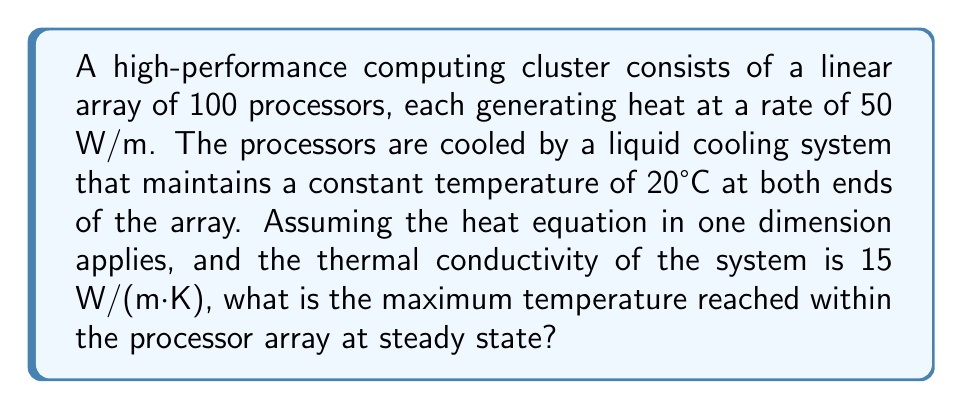Teach me how to tackle this problem. To solve this problem, we'll use the steady-state heat equation in one dimension:

$$-k\frac{d^2T}{dx^2} = q$$

Where:
$k$ is the thermal conductivity (15 W/(m·K))
$T$ is the temperature
$x$ is the position along the array
$q$ is the heat generation rate per unit length (50 W/m)

Step 1: Integrate the equation twice:

$$-k\frac{dT}{dx} = qx + C_1$$
$$-kT = \frac{1}{2}qx^2 + C_1x + C_2$$

Step 2: Apply boundary conditions:
At $x = 0$ and $x = L$ (where $L$ is the length of the array), $T = 20°C$

$$20 = -\frac{1}{2k}q(0)^2 - \frac{C_1}{k}(0) - \frac{C_2}{k}$$
$$20 = -\frac{1}{2k}qL^2 - \frac{C_1}{k}L - \frac{C_2}{k}$$

Step 3: Solve for constants:
$C_2 = -20k$
$C_1 = -\frac{1}{2}qL$

Step 4: Substitute back into the general solution:

$$T = -\frac{q}{2k}x^2 + \frac{qL}{2k}x + 20$$

Step 5: Find the maximum temperature by differentiating and setting to zero:

$$\frac{dT}{dx} = -\frac{q}{k}x + \frac{qL}{2k} = 0$$
$$x = \frac{L}{2}$$

Step 6: Calculate the maximum temperature:

$$T_{max} = -\frac{q}{2k}(\frac{L}{2})^2 + \frac{qL}{2k}(\frac{L}{2}) + 20$$
$$T_{max} = \frac{qL^2}{8k} + 20$$

Step 7: Calculate $L$ (length of the array):
Assuming each processor is 1 cm wide, $L = 1 \text{ m}$

Step 8: Substitute values:

$$T_{max} = \frac{50 \cdot 1^2}{8 \cdot 15} + 20 = 20.4167°C$$
Answer: 20.4167°C 